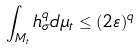<formula> <loc_0><loc_0><loc_500><loc_500>\int _ { M _ { t } } h _ { \sigma } ^ { q } d \mu _ { t } \leq ( 2 \varepsilon ) ^ { q }</formula> 